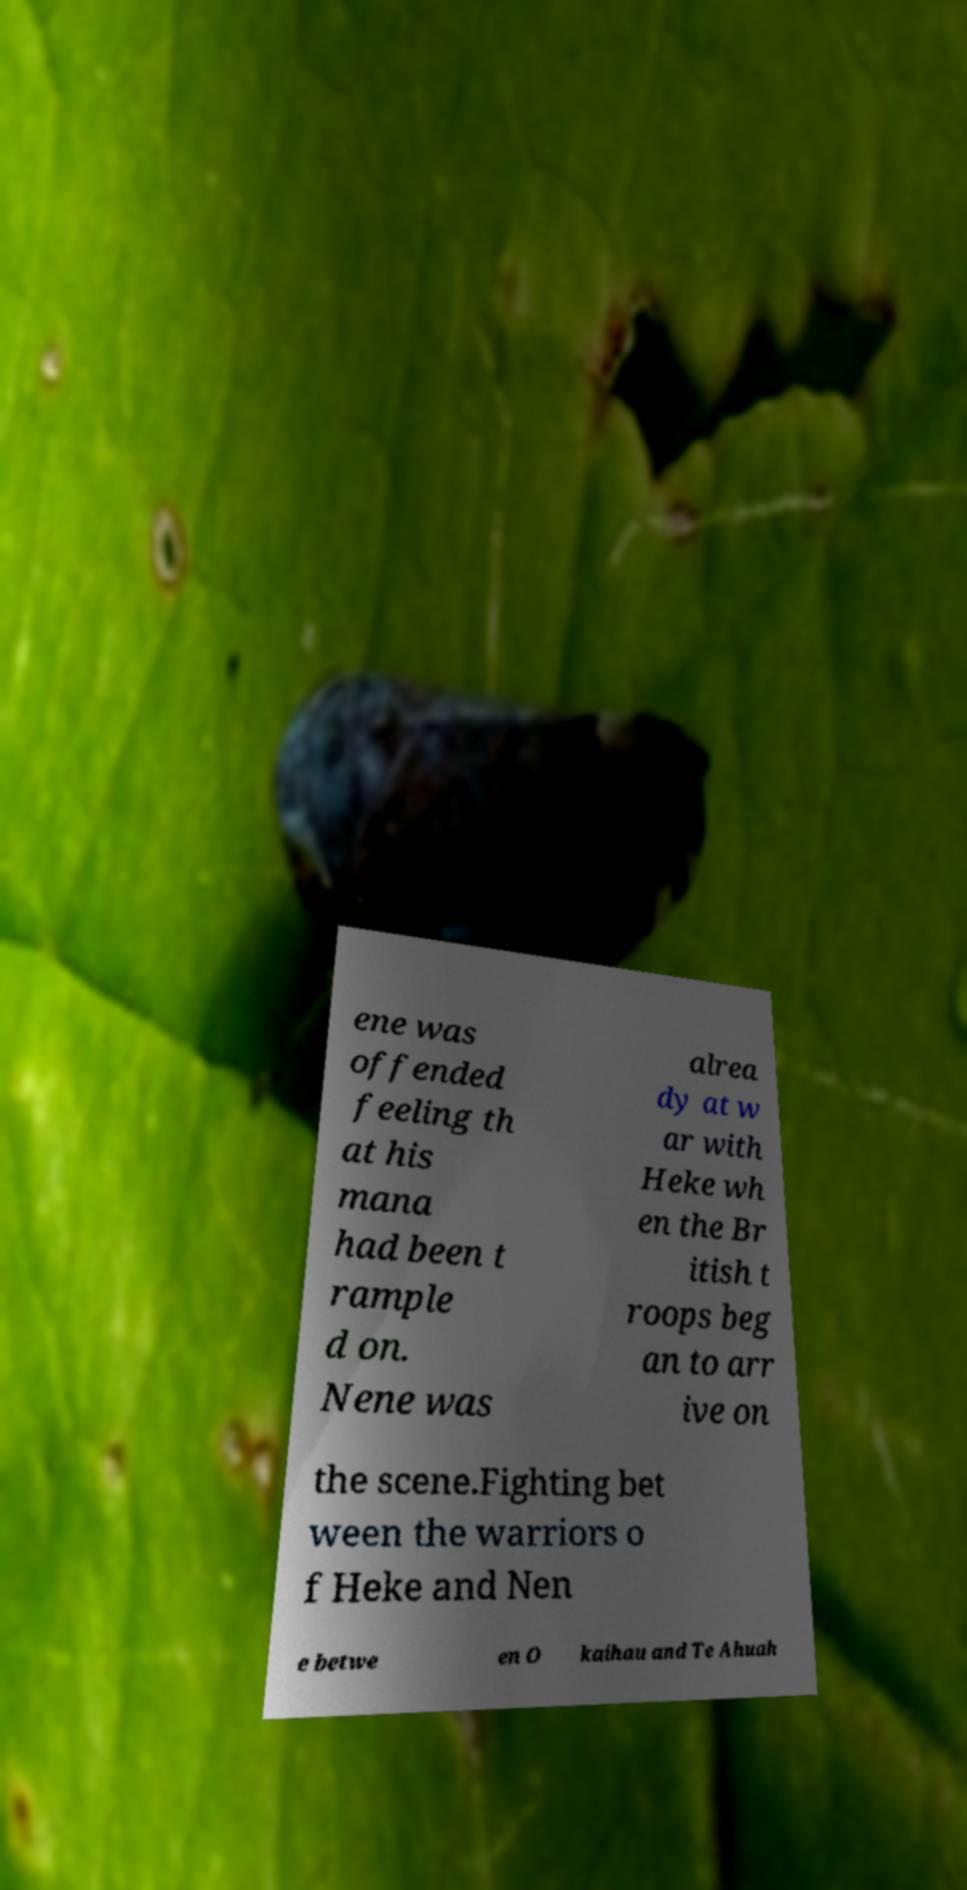Please read and relay the text visible in this image. What does it say? ene was offended feeling th at his mana had been t rample d on. Nene was alrea dy at w ar with Heke wh en the Br itish t roops beg an to arr ive on the scene.Fighting bet ween the warriors o f Heke and Nen e betwe en O kaihau and Te Ahuah 